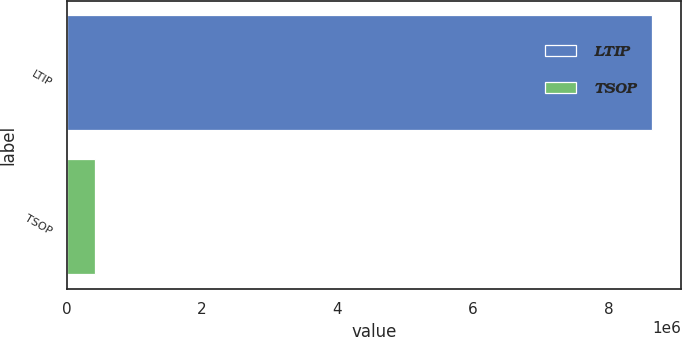Convert chart. <chart><loc_0><loc_0><loc_500><loc_500><bar_chart><fcel>LTIP<fcel>TSOP<nl><fcel>8.64411e+06<fcel>422973<nl></chart> 